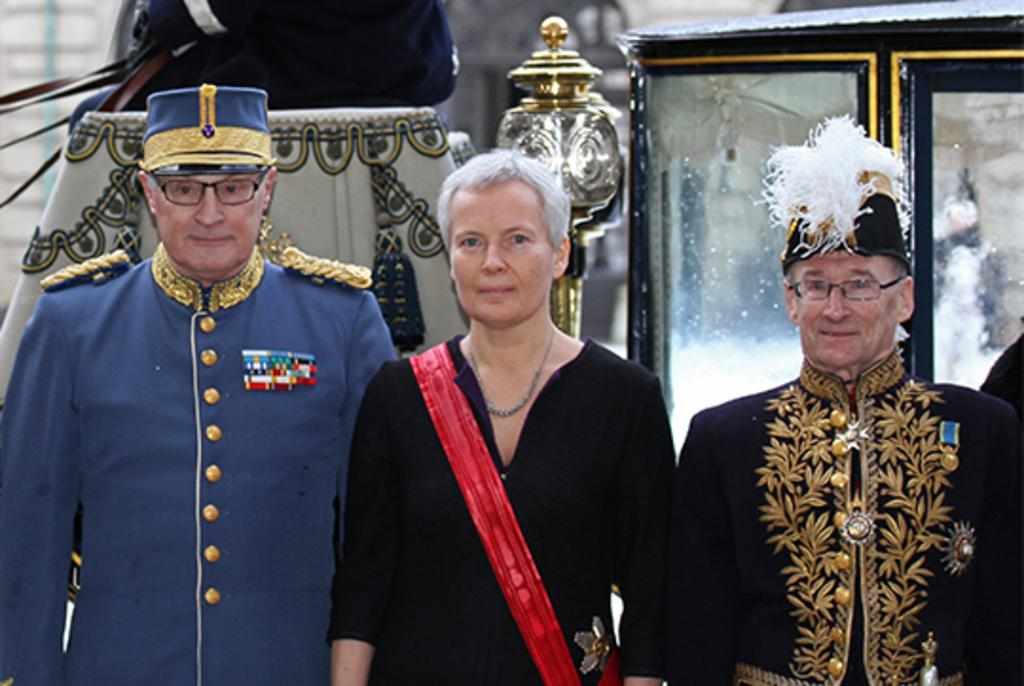How many people are present in the image? There are three people standing in the image. What can be seen in the background of the image? There are objects visible in the background of the image. Is there any indication of a specific location or structure in the background? There might be a building in the background of the image. What type of treatment is the grandmother receiving in the image? There is no grandmother or treatment present in the image. 